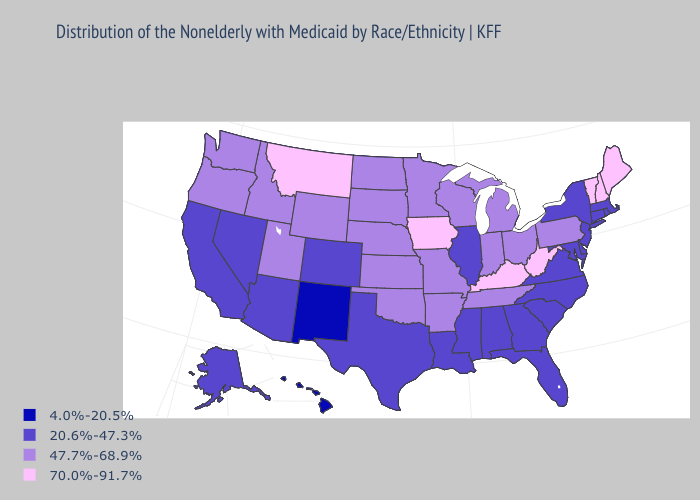Name the states that have a value in the range 20.6%-47.3%?
Give a very brief answer. Alabama, Alaska, Arizona, California, Colorado, Connecticut, Delaware, Florida, Georgia, Illinois, Louisiana, Maryland, Massachusetts, Mississippi, Nevada, New Jersey, New York, North Carolina, Rhode Island, South Carolina, Texas, Virginia. Does Wyoming have a lower value than Minnesota?
Give a very brief answer. No. Which states hav the highest value in the South?
Answer briefly. Kentucky, West Virginia. What is the value of Massachusetts?
Answer briefly. 20.6%-47.3%. Does Massachusetts have the lowest value in the Northeast?
Concise answer only. Yes. Name the states that have a value in the range 70.0%-91.7%?
Concise answer only. Iowa, Kentucky, Maine, Montana, New Hampshire, Vermont, West Virginia. How many symbols are there in the legend?
Short answer required. 4. Does Montana have the highest value in the West?
Answer briefly. Yes. What is the value of Nevada?
Keep it brief. 20.6%-47.3%. What is the lowest value in states that border Kansas?
Give a very brief answer. 20.6%-47.3%. Does the map have missing data?
Concise answer only. No. Does Alabama have the same value as South Carolina?
Be succinct. Yes. What is the lowest value in states that border Massachusetts?
Quick response, please. 20.6%-47.3%. Which states have the highest value in the USA?
Keep it brief. Iowa, Kentucky, Maine, Montana, New Hampshire, Vermont, West Virginia. What is the value of Kentucky?
Answer briefly. 70.0%-91.7%. 